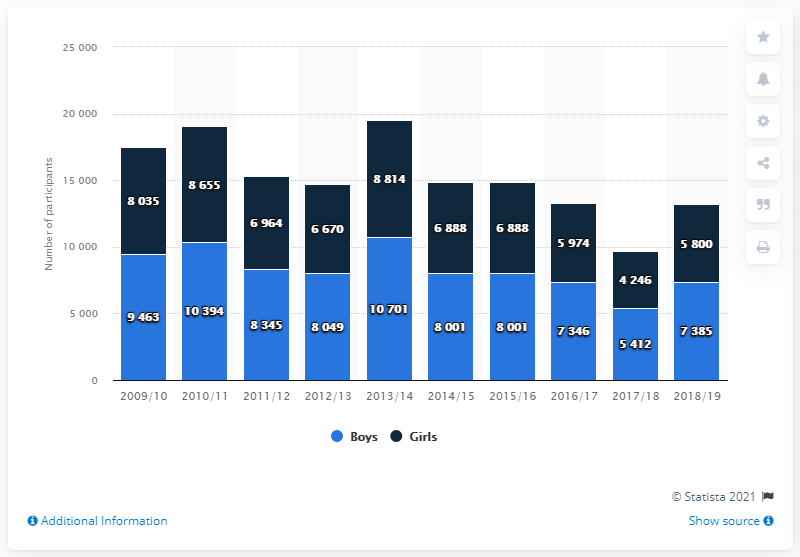Specify some key components in this picture. The peak in the number of participants was reached in the 2013/2014 season. In the 2018/19 academic year, a total of 7,385 boys participated in high school sports. The number of participants in the 2017/18 academic year was 9,658. 